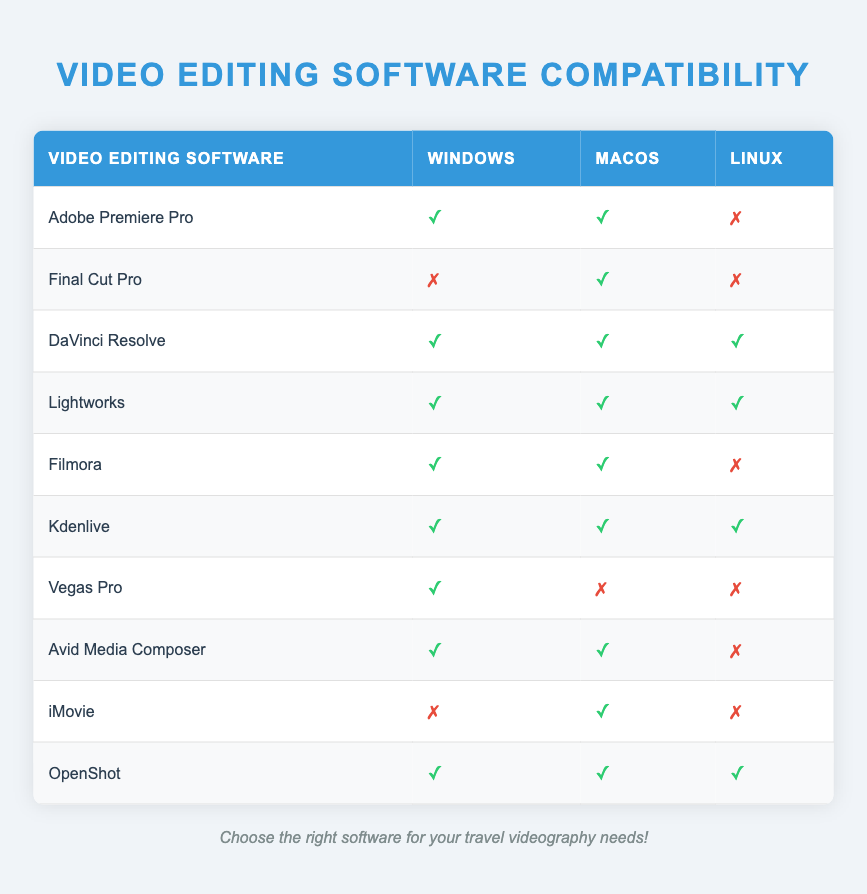What video editing software is compatible with macOS? By looking at the macOS column in the table, I can identify the software that has a check mark (✓) indicating compatibility. The software with a check mark for macOS are: Adobe Premiere Pro, Final Cut Pro, DaVinci Resolve, Lightworks, Filmora, Kdenlive, Avid Media Composer, and iMovie.
Answer: Adobe Premiere Pro, Final Cut Pro, DaVinci Resolve, Lightworks, Filmora, Kdenlive, Avid Media Composer, iMovie Which software is only compatible with Windows? I need to check the table for software that have a check mark for Windows and a cross mark (✗) for both macOS and Linux. Upon reviewing, I find that Vegas Pro is the only software that meets these criteria as it is the only one marked as compatible with Windows only.
Answer: Vegas Pro Is DaVinci Resolve compatible with all operating systems? To answer this, I will inspect the rows for DaVinci Resolve and check the symbols in all three operating system columns. The table shows that DaVinci Resolve has a check mark (✓) under Windows, macOS, and Linux, indicating compatibility with all operating systems.
Answer: Yes How many video editing software applications are compatible with Linux? I will start by counting the rows where the Linux column has a check mark (✓). The applications that are compatible with Linux according to the table are: DaVinci Resolve, Lightworks, Kdenlive, and OpenShot, which totals to four software.
Answer: 4 Which software offers compatibility with both Windows and macOS but not Linux? I will look for software that has check marks for Windows and macOS, and a cross mark for Linux. Reviewing the table, I identify Filmora and Avid Media Composer as the only software that fits this description.
Answer: Filmora, Avid Media Composer Does all software listed in the table support either Windows or macOS? I need to check if there's any software that has a cross mark (✗) for both Windows and macOS. Upon checking all the rows, I can confirm that each software listed is compatible with at least one of the two operating systems.
Answer: Yes What is the total number of editing software options available in the table? I can find this by counting the number of rows listed in the table. There are a total of ten rows of software, indicating that there are ten different video editing options available.
Answer: 10 Which software can be used for video editing on all three operating systems? To determine this, I will look for software that has check marks (✓) in all three operating system columns. Scanning the table, I see that DaVinci Resolve, Lightworks, Kdenlive, and OpenShot are compatible with all three, making them suitable for editing on any system.
Answer: DaVinci Resolve, Lightworks, Kdenlive, OpenShot 